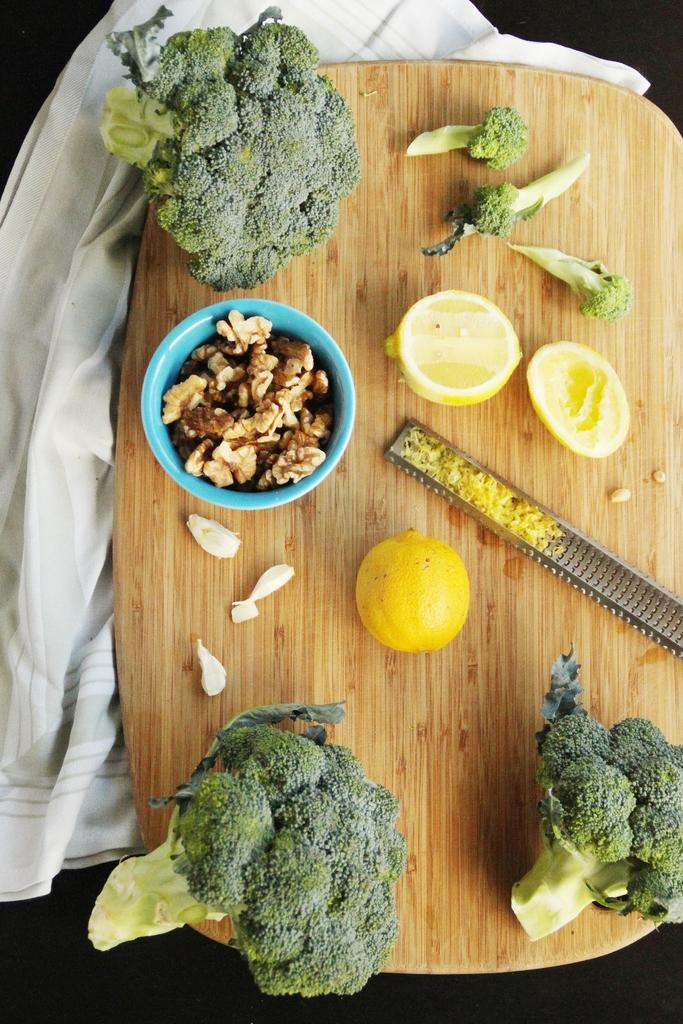What type of vegetable is placed on the table in the image? There is broccoli placed on the table. What other food item can be seen on the table? There are lemons placed on the table. What is under the table in the image? There is a cloth under the table. How many dogs are sitting on the table in the image? There are no dogs present in the image; it only features broccoli, lemons, and a cloth under the table. 